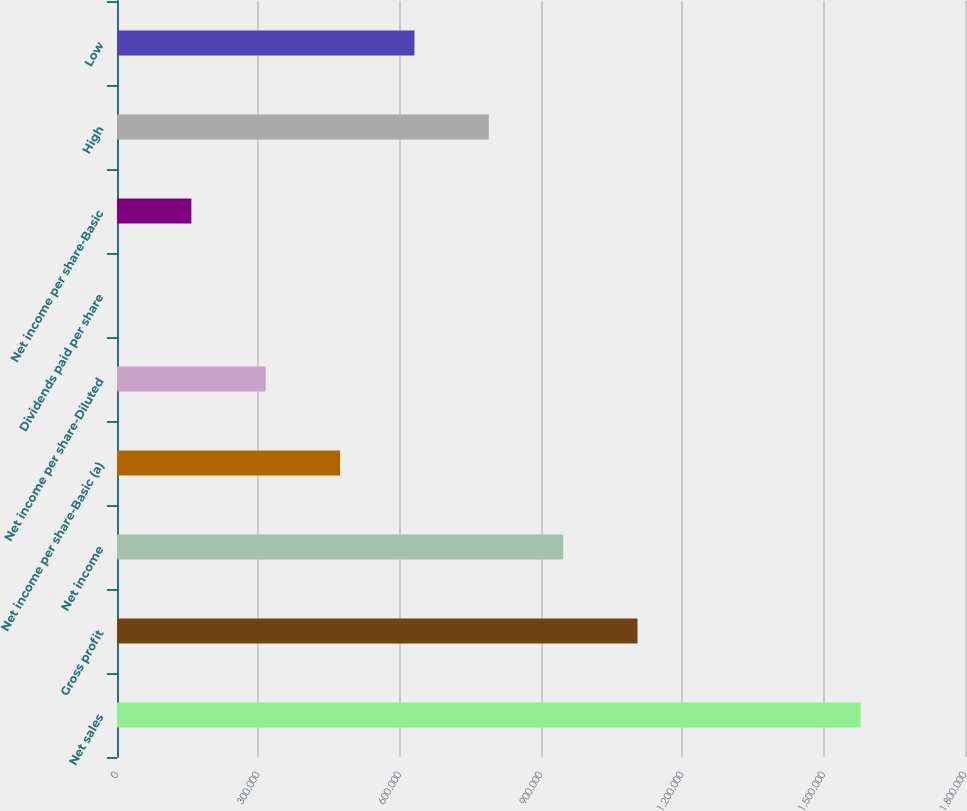<chart> <loc_0><loc_0><loc_500><loc_500><bar_chart><fcel>Net sales<fcel>Gross profit<fcel>Net income<fcel>Net income per share-Basic (a)<fcel>Net income per share-Diluted<fcel>Dividends paid per share<fcel>Net income per share-Basic<fcel>High<fcel>Low<nl><fcel>1.57835e+06<fcel>1.10485e+06<fcel>947010<fcel>473505<fcel>315670<fcel>0.48<fcel>157835<fcel>789175<fcel>631340<nl></chart> 